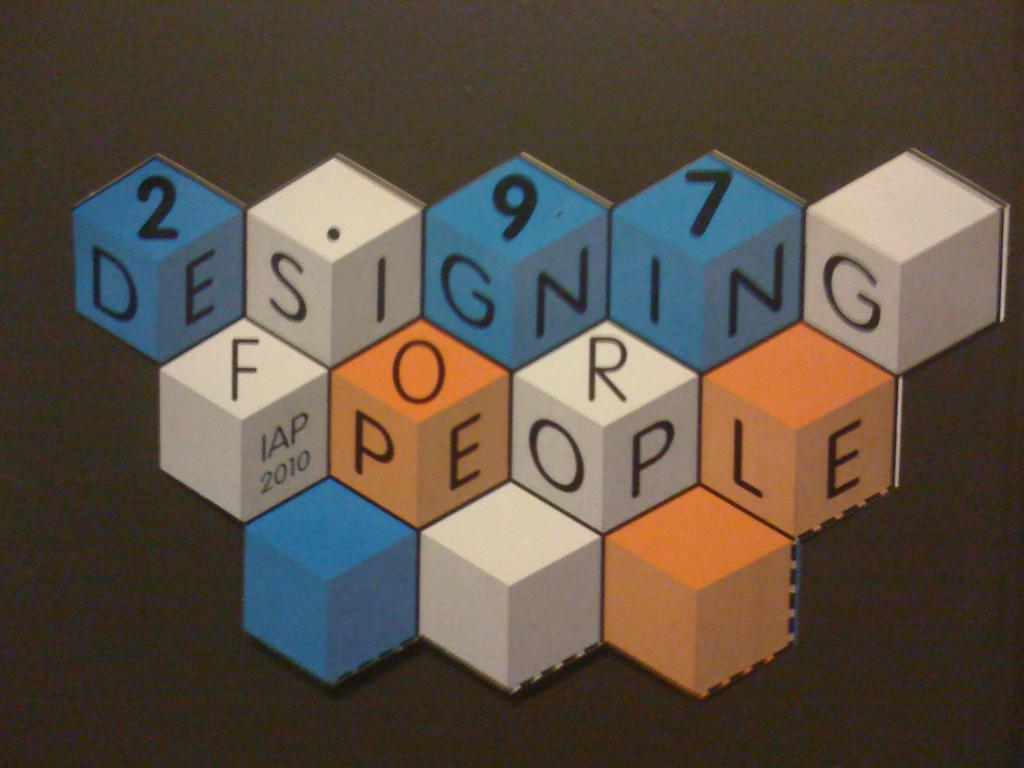<image>
Describe the image concisely. The message, "Designing for People" is arranged in a creative geometric design. 